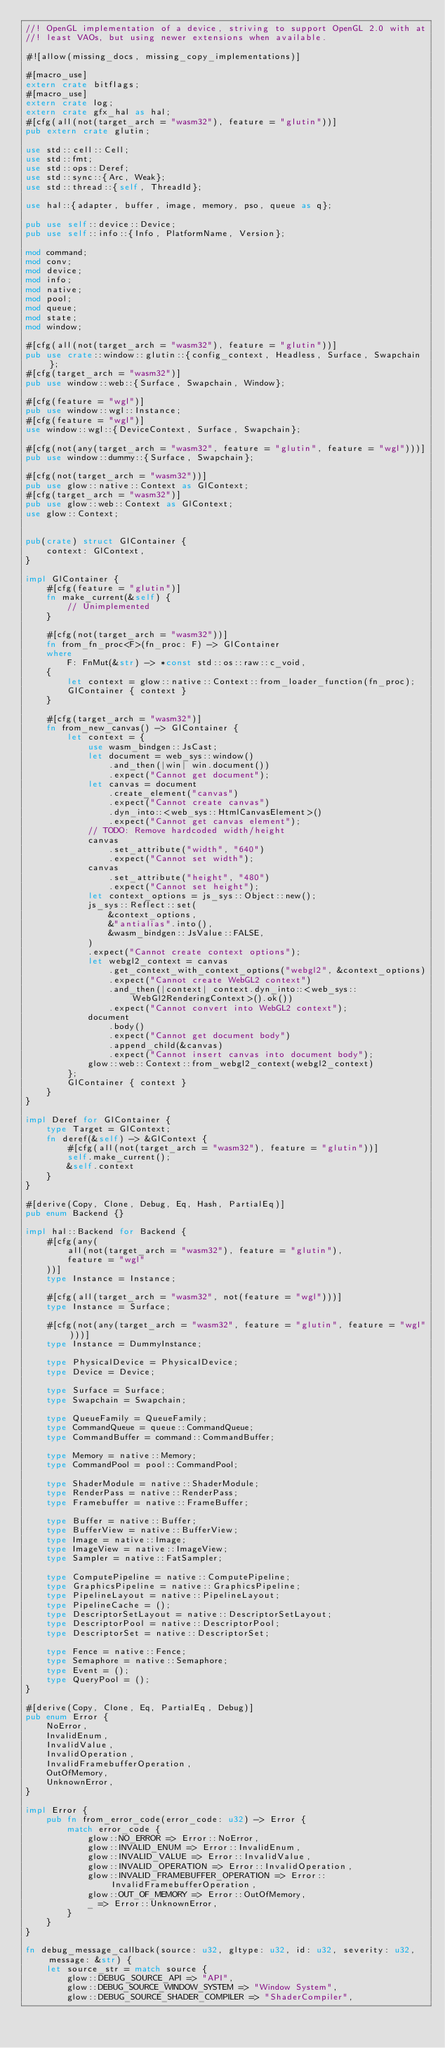<code> <loc_0><loc_0><loc_500><loc_500><_Rust_>//! OpenGL implementation of a device, striving to support OpenGL 2.0 with at
//! least VAOs, but using newer extensions when available.

#![allow(missing_docs, missing_copy_implementations)]

#[macro_use]
extern crate bitflags;
#[macro_use]
extern crate log;
extern crate gfx_hal as hal;
#[cfg(all(not(target_arch = "wasm32"), feature = "glutin"))]
pub extern crate glutin;

use std::cell::Cell;
use std::fmt;
use std::ops::Deref;
use std::sync::{Arc, Weak};
use std::thread::{self, ThreadId};

use hal::{adapter, buffer, image, memory, pso, queue as q};

pub use self::device::Device;
pub use self::info::{Info, PlatformName, Version};

mod command;
mod conv;
mod device;
mod info;
mod native;
mod pool;
mod queue;
mod state;
mod window;

#[cfg(all(not(target_arch = "wasm32"), feature = "glutin"))]
pub use crate::window::glutin::{config_context, Headless, Surface, Swapchain};
#[cfg(target_arch = "wasm32")]
pub use window::web::{Surface, Swapchain, Window};

#[cfg(feature = "wgl")]
pub use window::wgl::Instance;
#[cfg(feature = "wgl")]
use window::wgl::{DeviceContext, Surface, Swapchain};

#[cfg(not(any(target_arch = "wasm32", feature = "glutin", feature = "wgl")))]
pub use window::dummy::{Surface, Swapchain};

#[cfg(not(target_arch = "wasm32"))]
pub use glow::native::Context as GlContext;
#[cfg(target_arch = "wasm32")]
pub use glow::web::Context as GlContext;
use glow::Context;


pub(crate) struct GlContainer {
    context: GlContext,
}

impl GlContainer {
    #[cfg(feature = "glutin")]
    fn make_current(&self) {
        // Unimplemented
    }

    #[cfg(not(target_arch = "wasm32"))]
    fn from_fn_proc<F>(fn_proc: F) -> GlContainer
    where
        F: FnMut(&str) -> *const std::os::raw::c_void,
    {
        let context = glow::native::Context::from_loader_function(fn_proc);
        GlContainer { context }
    }

    #[cfg(target_arch = "wasm32")]
    fn from_new_canvas() -> GlContainer {
        let context = {
            use wasm_bindgen::JsCast;
            let document = web_sys::window()
                .and_then(|win| win.document())
                .expect("Cannot get document");
            let canvas = document
                .create_element("canvas")
                .expect("Cannot create canvas")
                .dyn_into::<web_sys::HtmlCanvasElement>()
                .expect("Cannot get canvas element");
            // TODO: Remove hardcoded width/height
            canvas
                .set_attribute("width", "640")
                .expect("Cannot set width");
            canvas
                .set_attribute("height", "480")
                .expect("Cannot set height");
            let context_options = js_sys::Object::new();
            js_sys::Reflect::set(
                &context_options,
                &"antialias".into(),
                &wasm_bindgen::JsValue::FALSE,
            )
            .expect("Cannot create context options");
            let webgl2_context = canvas
                .get_context_with_context_options("webgl2", &context_options)
                .expect("Cannot create WebGL2 context")
                .and_then(|context| context.dyn_into::<web_sys::WebGl2RenderingContext>().ok())
                .expect("Cannot convert into WebGL2 context");
            document
                .body()
                .expect("Cannot get document body")
                .append_child(&canvas)
                .expect("Cannot insert canvas into document body");
            glow::web::Context::from_webgl2_context(webgl2_context)
        };
        GlContainer { context }
    }
}

impl Deref for GlContainer {
    type Target = GlContext;
    fn deref(&self) -> &GlContext {
        #[cfg(all(not(target_arch = "wasm32"), feature = "glutin"))]
        self.make_current();
        &self.context
    }
}

#[derive(Copy, Clone, Debug, Eq, Hash, PartialEq)]
pub enum Backend {}

impl hal::Backend for Backend {
    #[cfg(any(
        all(not(target_arch = "wasm32"), feature = "glutin"),
        feature = "wgl"
    ))]
    type Instance = Instance;

    #[cfg(all(target_arch = "wasm32", not(feature = "wgl")))]
    type Instance = Surface;

    #[cfg(not(any(target_arch = "wasm32", feature = "glutin", feature = "wgl")))]
    type Instance = DummyInstance;

    type PhysicalDevice = PhysicalDevice;
    type Device = Device;

    type Surface = Surface;
    type Swapchain = Swapchain;

    type QueueFamily = QueueFamily;
    type CommandQueue = queue::CommandQueue;
    type CommandBuffer = command::CommandBuffer;

    type Memory = native::Memory;
    type CommandPool = pool::CommandPool;

    type ShaderModule = native::ShaderModule;
    type RenderPass = native::RenderPass;
    type Framebuffer = native::FrameBuffer;

    type Buffer = native::Buffer;
    type BufferView = native::BufferView;
    type Image = native::Image;
    type ImageView = native::ImageView;
    type Sampler = native::FatSampler;

    type ComputePipeline = native::ComputePipeline;
    type GraphicsPipeline = native::GraphicsPipeline;
    type PipelineLayout = native::PipelineLayout;
    type PipelineCache = ();
    type DescriptorSetLayout = native::DescriptorSetLayout;
    type DescriptorPool = native::DescriptorPool;
    type DescriptorSet = native::DescriptorSet;

    type Fence = native::Fence;
    type Semaphore = native::Semaphore;
    type Event = ();
    type QueryPool = ();
}

#[derive(Copy, Clone, Eq, PartialEq, Debug)]
pub enum Error {
    NoError,
    InvalidEnum,
    InvalidValue,
    InvalidOperation,
    InvalidFramebufferOperation,
    OutOfMemory,
    UnknownError,
}

impl Error {
    pub fn from_error_code(error_code: u32) -> Error {
        match error_code {
            glow::NO_ERROR => Error::NoError,
            glow::INVALID_ENUM => Error::InvalidEnum,
            glow::INVALID_VALUE => Error::InvalidValue,
            glow::INVALID_OPERATION => Error::InvalidOperation,
            glow::INVALID_FRAMEBUFFER_OPERATION => Error::InvalidFramebufferOperation,
            glow::OUT_OF_MEMORY => Error::OutOfMemory,
            _ => Error::UnknownError,
        }
    }
}

fn debug_message_callback(source: u32, gltype: u32, id: u32, severity: u32, message: &str) {
    let source_str = match source {
        glow::DEBUG_SOURCE_API => "API",
        glow::DEBUG_SOURCE_WINDOW_SYSTEM => "Window System",
        glow::DEBUG_SOURCE_SHADER_COMPILER => "ShaderCompiler",</code> 